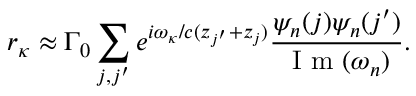<formula> <loc_0><loc_0><loc_500><loc_500>r _ { \kappa } \approx { \Gamma _ { 0 } } \sum _ { j , j ^ { \prime } } { { e ^ { i \omega _ { \kappa } / c ( { z _ { j ^ { \prime } } } + { z _ { j } } ) } } \frac { \psi _ { n } ( j ) \psi _ { n } ( j ^ { \prime } ) } { I m ( \omega _ { n } ) } } .</formula> 